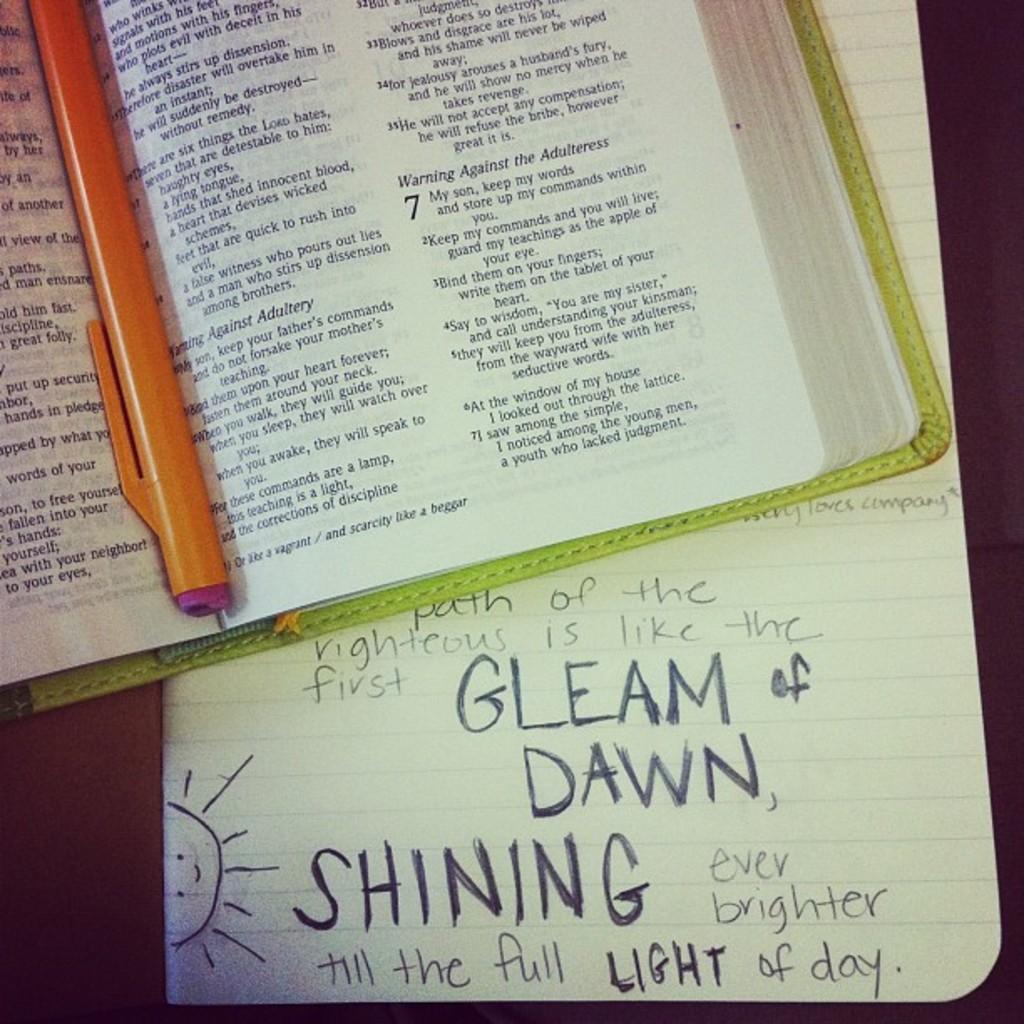What is the path of the righteous like?
Offer a terse response. The first gleam of dawn. Finish the statement: "the gleam of dawn, ____ ..."?
Make the answer very short. Shining. 